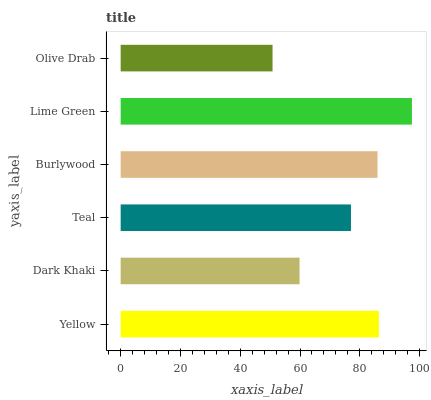Is Olive Drab the minimum?
Answer yes or no. Yes. Is Lime Green the maximum?
Answer yes or no. Yes. Is Dark Khaki the minimum?
Answer yes or no. No. Is Dark Khaki the maximum?
Answer yes or no. No. Is Yellow greater than Dark Khaki?
Answer yes or no. Yes. Is Dark Khaki less than Yellow?
Answer yes or no. Yes. Is Dark Khaki greater than Yellow?
Answer yes or no. No. Is Yellow less than Dark Khaki?
Answer yes or no. No. Is Burlywood the high median?
Answer yes or no. Yes. Is Teal the low median?
Answer yes or no. Yes. Is Olive Drab the high median?
Answer yes or no. No. Is Burlywood the low median?
Answer yes or no. No. 